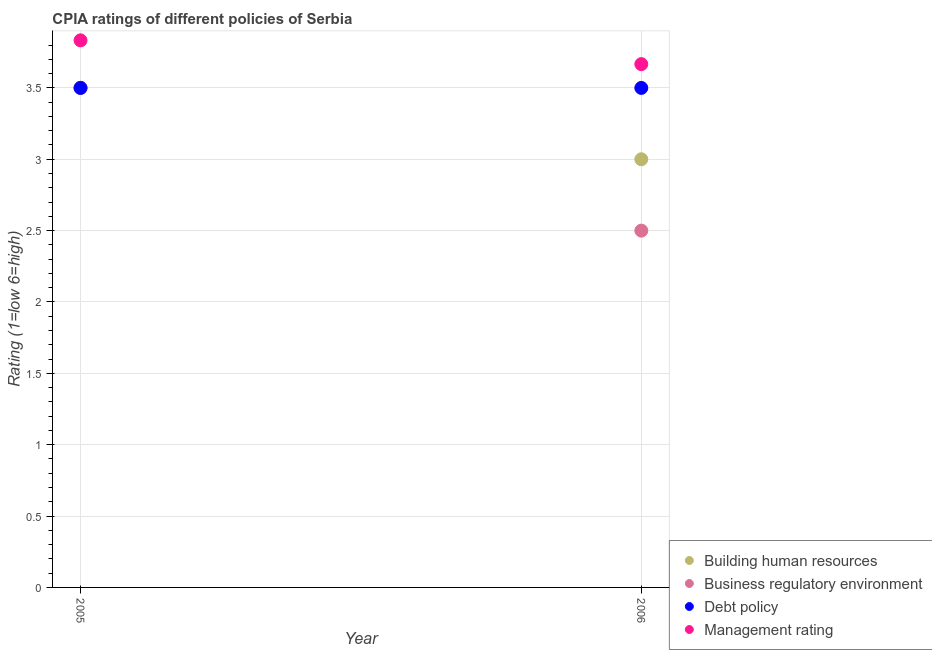Is the number of dotlines equal to the number of legend labels?
Your answer should be compact. Yes. What is the cpia rating of management in 2006?
Ensure brevity in your answer.  3.67. Across all years, what is the minimum cpia rating of building human resources?
Offer a very short reply. 3. In which year was the cpia rating of management maximum?
Ensure brevity in your answer.  2005. In which year was the cpia rating of debt policy minimum?
Offer a terse response. 2005. What is the difference between the cpia rating of business regulatory environment in 2005 and that in 2006?
Ensure brevity in your answer.  1. What is the difference between the cpia rating of building human resources in 2006 and the cpia rating of management in 2005?
Your answer should be compact. -0.83. In the year 2006, what is the difference between the cpia rating of management and cpia rating of debt policy?
Ensure brevity in your answer.  0.17. In how many years, is the cpia rating of building human resources greater than 2.1?
Ensure brevity in your answer.  2. What is the ratio of the cpia rating of building human resources in 2005 to that in 2006?
Provide a succinct answer. 1.17. In how many years, is the cpia rating of management greater than the average cpia rating of management taken over all years?
Give a very brief answer. 1. Is it the case that in every year, the sum of the cpia rating of building human resources and cpia rating of business regulatory environment is greater than the cpia rating of debt policy?
Your response must be concise. Yes. How many dotlines are there?
Provide a short and direct response. 4. What is the difference between two consecutive major ticks on the Y-axis?
Provide a short and direct response. 0.5. Are the values on the major ticks of Y-axis written in scientific E-notation?
Make the answer very short. No. Does the graph contain any zero values?
Ensure brevity in your answer.  No. How are the legend labels stacked?
Ensure brevity in your answer.  Vertical. What is the title of the graph?
Your answer should be compact. CPIA ratings of different policies of Serbia. What is the label or title of the X-axis?
Make the answer very short. Year. What is the Rating (1=low 6=high) of Business regulatory environment in 2005?
Your answer should be very brief. 3.5. What is the Rating (1=low 6=high) in Debt policy in 2005?
Your answer should be compact. 3.5. What is the Rating (1=low 6=high) of Management rating in 2005?
Provide a short and direct response. 3.83. What is the Rating (1=low 6=high) of Debt policy in 2006?
Offer a very short reply. 3.5. What is the Rating (1=low 6=high) in Management rating in 2006?
Provide a short and direct response. 3.67. Across all years, what is the maximum Rating (1=low 6=high) of Building human resources?
Your answer should be very brief. 3.5. Across all years, what is the maximum Rating (1=low 6=high) in Business regulatory environment?
Make the answer very short. 3.5. Across all years, what is the maximum Rating (1=low 6=high) in Debt policy?
Your response must be concise. 3.5. Across all years, what is the maximum Rating (1=low 6=high) in Management rating?
Provide a succinct answer. 3.83. Across all years, what is the minimum Rating (1=low 6=high) of Business regulatory environment?
Offer a very short reply. 2.5. Across all years, what is the minimum Rating (1=low 6=high) of Management rating?
Your answer should be compact. 3.67. What is the total Rating (1=low 6=high) of Building human resources in the graph?
Keep it short and to the point. 6.5. What is the total Rating (1=low 6=high) in Business regulatory environment in the graph?
Make the answer very short. 6. What is the difference between the Rating (1=low 6=high) of Building human resources in 2005 and the Rating (1=low 6=high) of Business regulatory environment in 2006?
Keep it short and to the point. 1. What is the difference between the Rating (1=low 6=high) in Building human resources in 2005 and the Rating (1=low 6=high) in Debt policy in 2006?
Your answer should be very brief. 0. What is the difference between the Rating (1=low 6=high) in Building human resources in 2005 and the Rating (1=low 6=high) in Management rating in 2006?
Offer a terse response. -0.17. What is the difference between the Rating (1=low 6=high) in Business regulatory environment in 2005 and the Rating (1=low 6=high) in Debt policy in 2006?
Provide a succinct answer. 0. What is the difference between the Rating (1=low 6=high) of Business regulatory environment in 2005 and the Rating (1=low 6=high) of Management rating in 2006?
Offer a very short reply. -0.17. What is the average Rating (1=low 6=high) in Building human resources per year?
Your answer should be compact. 3.25. What is the average Rating (1=low 6=high) in Business regulatory environment per year?
Your answer should be compact. 3. What is the average Rating (1=low 6=high) of Debt policy per year?
Offer a very short reply. 3.5. What is the average Rating (1=low 6=high) in Management rating per year?
Your answer should be very brief. 3.75. In the year 2005, what is the difference between the Rating (1=low 6=high) in Building human resources and Rating (1=low 6=high) in Business regulatory environment?
Provide a succinct answer. 0. In the year 2005, what is the difference between the Rating (1=low 6=high) of Building human resources and Rating (1=low 6=high) of Debt policy?
Your answer should be very brief. 0. In the year 2005, what is the difference between the Rating (1=low 6=high) in Business regulatory environment and Rating (1=low 6=high) in Management rating?
Ensure brevity in your answer.  -0.33. In the year 2005, what is the difference between the Rating (1=low 6=high) of Debt policy and Rating (1=low 6=high) of Management rating?
Ensure brevity in your answer.  -0.33. In the year 2006, what is the difference between the Rating (1=low 6=high) in Building human resources and Rating (1=low 6=high) in Business regulatory environment?
Offer a terse response. 0.5. In the year 2006, what is the difference between the Rating (1=low 6=high) in Building human resources and Rating (1=low 6=high) in Management rating?
Offer a terse response. -0.67. In the year 2006, what is the difference between the Rating (1=low 6=high) in Business regulatory environment and Rating (1=low 6=high) in Management rating?
Offer a very short reply. -1.17. In the year 2006, what is the difference between the Rating (1=low 6=high) of Debt policy and Rating (1=low 6=high) of Management rating?
Your answer should be compact. -0.17. What is the ratio of the Rating (1=low 6=high) of Management rating in 2005 to that in 2006?
Offer a terse response. 1.05. What is the difference between the highest and the second highest Rating (1=low 6=high) in Building human resources?
Provide a succinct answer. 0.5. What is the difference between the highest and the second highest Rating (1=low 6=high) in Management rating?
Your answer should be compact. 0.17. What is the difference between the highest and the lowest Rating (1=low 6=high) in Building human resources?
Keep it short and to the point. 0.5. What is the difference between the highest and the lowest Rating (1=low 6=high) of Management rating?
Give a very brief answer. 0.17. 